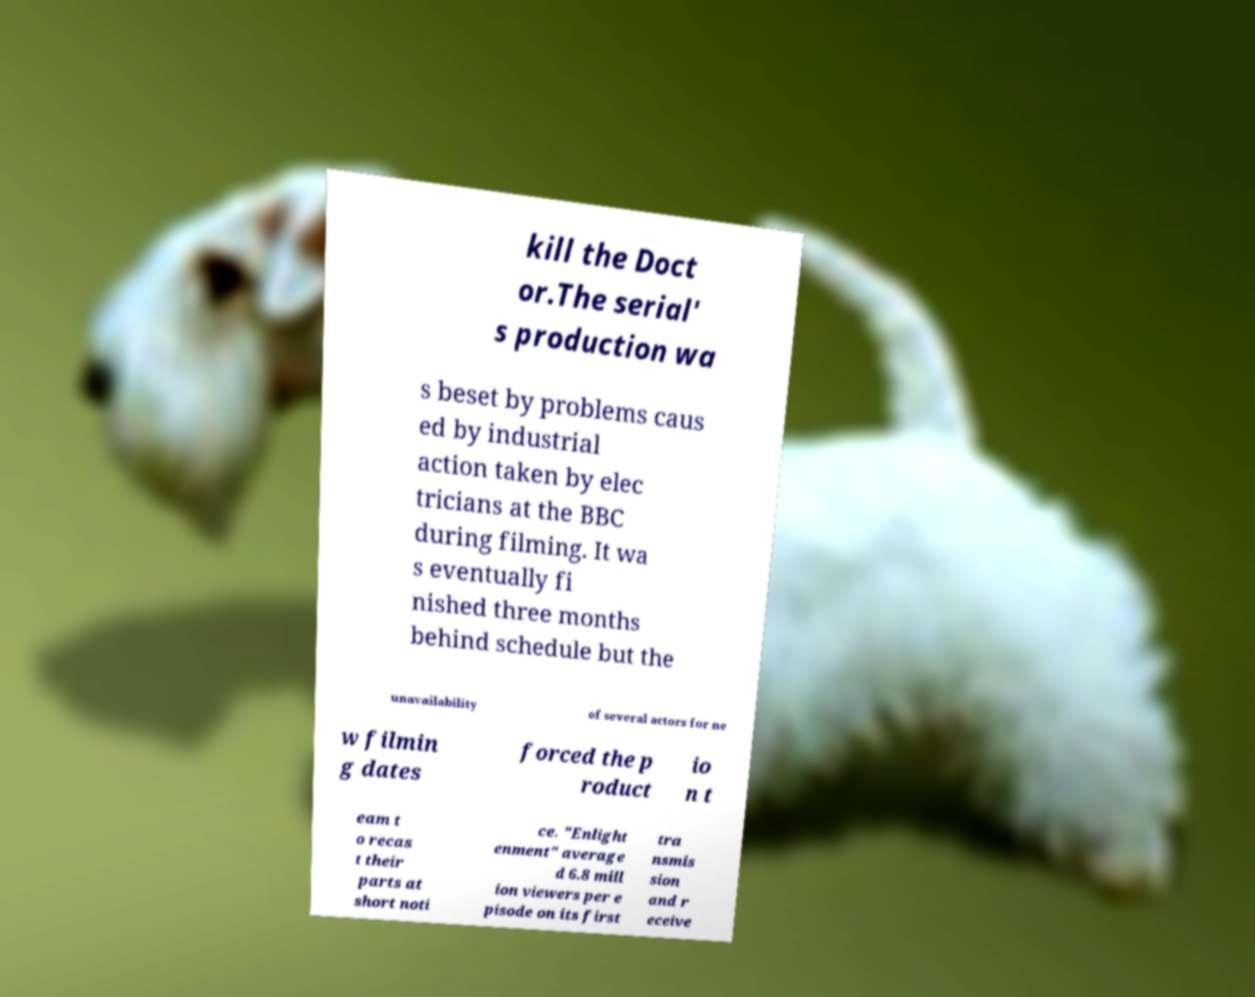What messages or text are displayed in this image? I need them in a readable, typed format. kill the Doct or.The serial' s production wa s beset by problems caus ed by industrial action taken by elec tricians at the BBC during filming. It wa s eventually fi nished three months behind schedule but the unavailability of several actors for ne w filmin g dates forced the p roduct io n t eam t o recas t their parts at short noti ce. "Enlight enment" average d 6.8 mill ion viewers per e pisode on its first tra nsmis sion and r eceive 